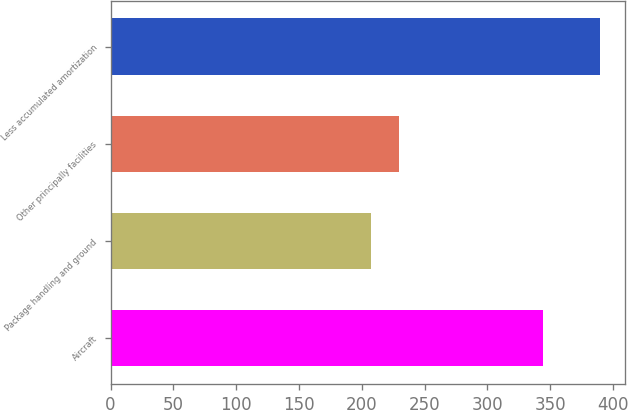<chart> <loc_0><loc_0><loc_500><loc_500><bar_chart><fcel>Aircraft<fcel>Package handling and ground<fcel>Other principally facilities<fcel>Less accumulated amortization<nl><fcel>344<fcel>207<fcel>230<fcel>390<nl></chart> 